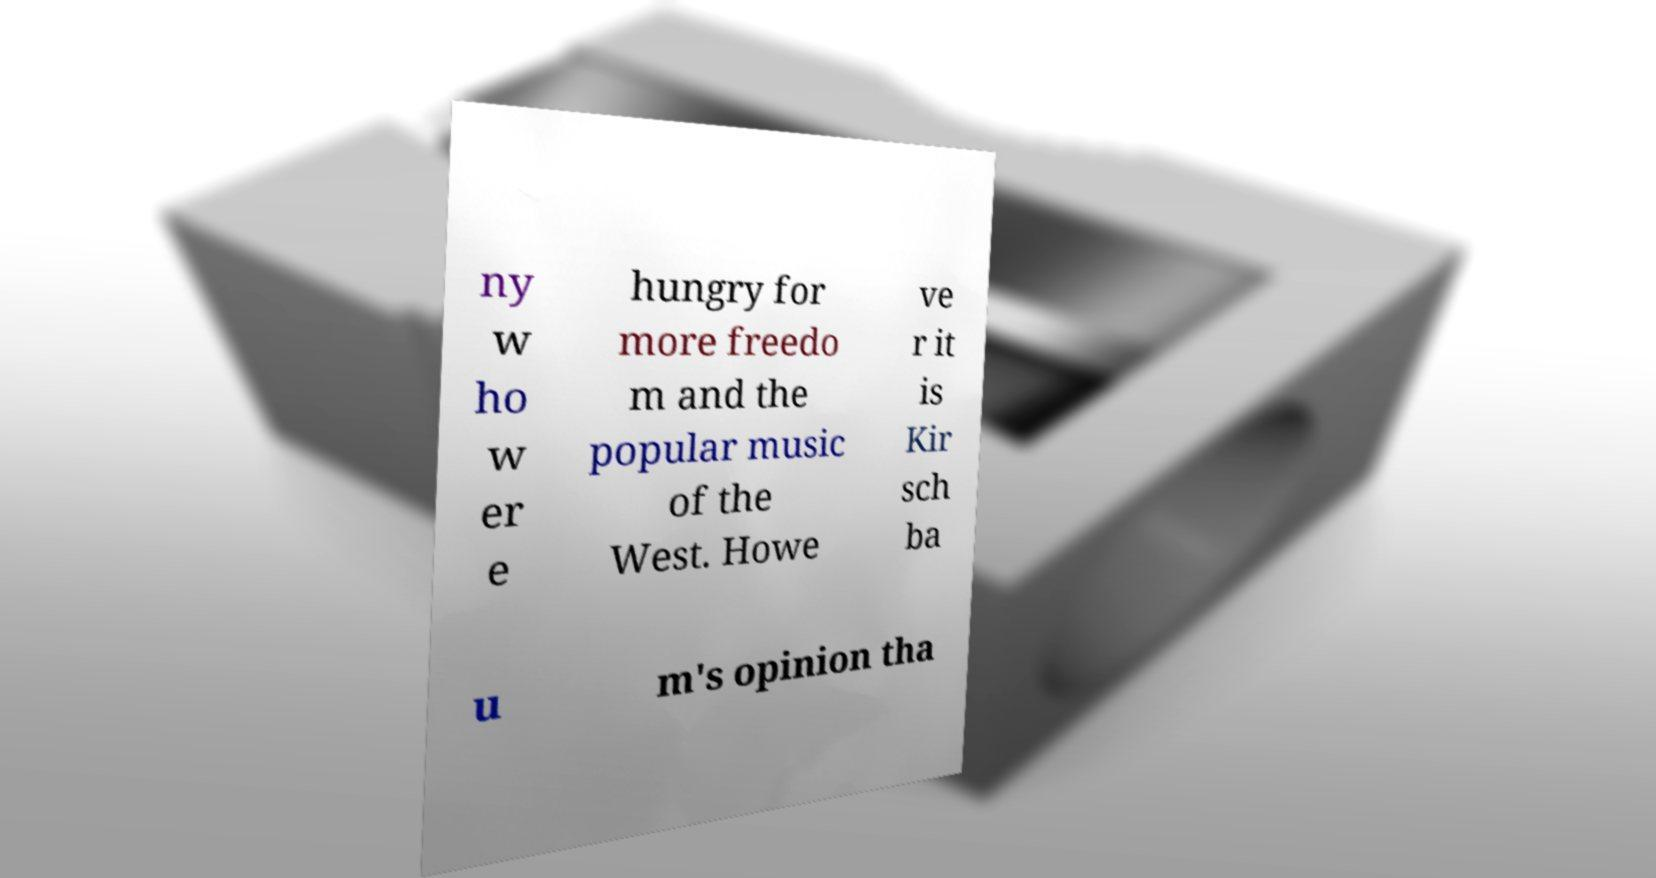What messages or text are displayed in this image? I need them in a readable, typed format. ny w ho w er e hungry for more freedo m and the popular music of the West. Howe ve r it is Kir sch ba u m's opinion tha 